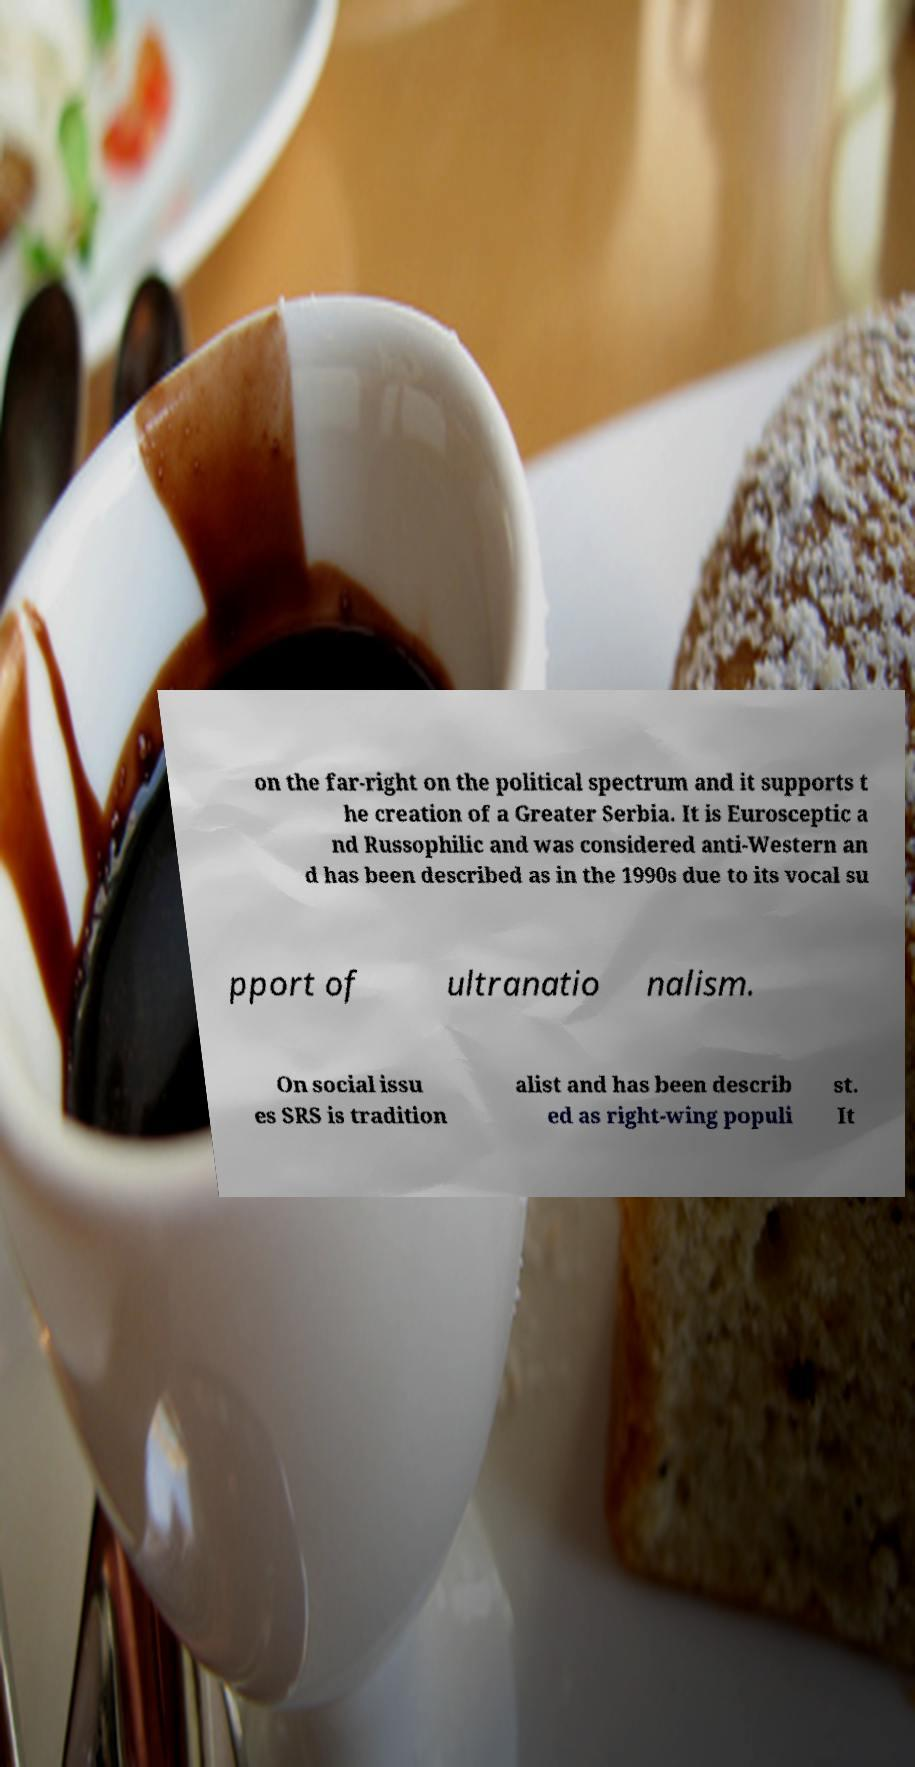What messages or text are displayed in this image? I need them in a readable, typed format. on the far-right on the political spectrum and it supports t he creation of a Greater Serbia. It is Eurosceptic a nd Russophilic and was considered anti-Western an d has been described as in the 1990s due to its vocal su pport of ultranatio nalism. On social issu es SRS is tradition alist and has been describ ed as right-wing populi st. It 